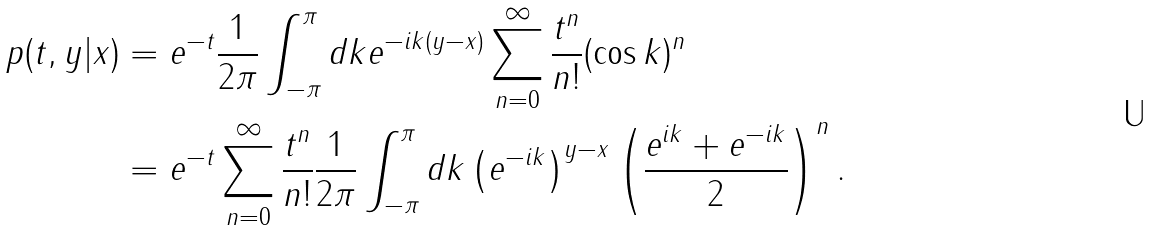Convert formula to latex. <formula><loc_0><loc_0><loc_500><loc_500>p ( t , y | x ) & = e ^ { - t } \frac { 1 } { 2 \pi } \int _ { - \pi } ^ { \pi } d k e ^ { - i k ( y - x ) } \sum _ { n = 0 } ^ { \infty } \frac { t ^ { n } } { n ! } ( \cos k ) ^ { n } \\ & = e ^ { - t } \sum _ { n = 0 } ^ { \infty } \frac { t ^ { n } } { n ! } \frac { 1 } { 2 \pi } \int _ { - \pi } ^ { \pi } d k \left ( e ^ { - i k } \right ) ^ { y - x } \left ( \frac { e ^ { i k } + e ^ { - i k } } { 2 } \right ) ^ { n } .</formula> 